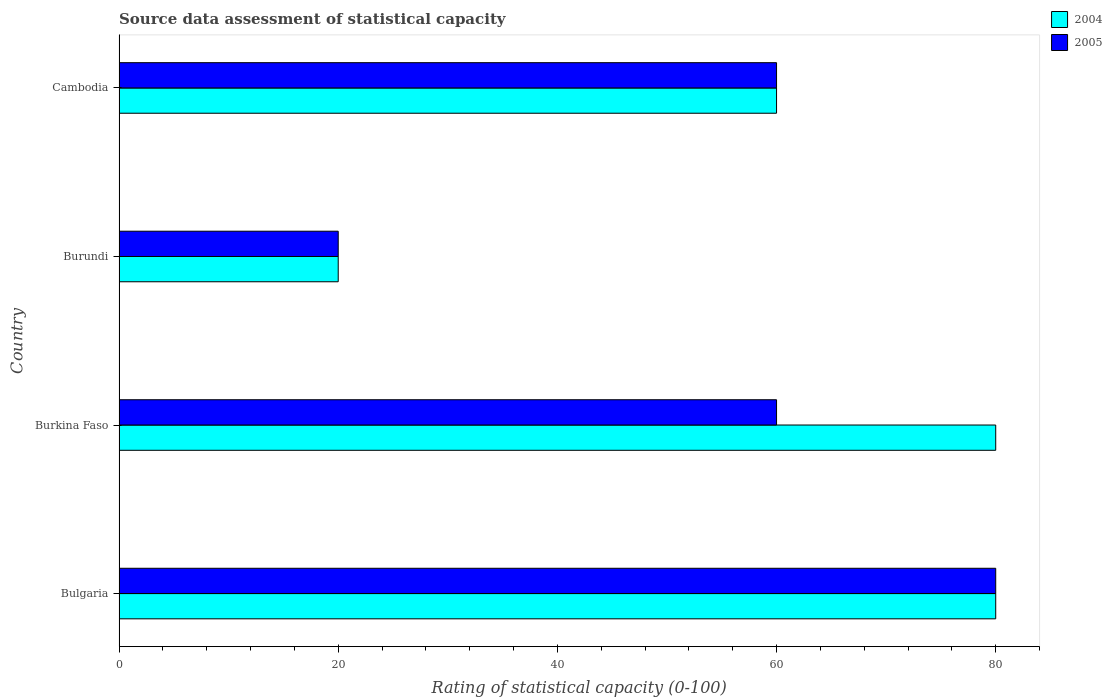How many different coloured bars are there?
Keep it short and to the point. 2. How many groups of bars are there?
Provide a succinct answer. 4. How many bars are there on the 1st tick from the top?
Keep it short and to the point. 2. What is the label of the 2nd group of bars from the top?
Ensure brevity in your answer.  Burundi. What is the rating of statistical capacity in 2004 in Cambodia?
Offer a very short reply. 60. Across all countries, what is the maximum rating of statistical capacity in 2004?
Give a very brief answer. 80. In which country was the rating of statistical capacity in 2004 maximum?
Your answer should be very brief. Bulgaria. In which country was the rating of statistical capacity in 2005 minimum?
Your answer should be very brief. Burundi. What is the total rating of statistical capacity in 2005 in the graph?
Give a very brief answer. 220. What is the difference between the rating of statistical capacity in 2004 in Bulgaria and the rating of statistical capacity in 2005 in Burundi?
Make the answer very short. 60. In how many countries, is the rating of statistical capacity in 2004 greater than 76 ?
Offer a terse response. 2. What is the ratio of the rating of statistical capacity in 2004 in Bulgaria to that in Burundi?
Provide a succinct answer. 4. Is the difference between the rating of statistical capacity in 2004 in Bulgaria and Burkina Faso greater than the difference between the rating of statistical capacity in 2005 in Bulgaria and Burkina Faso?
Your response must be concise. No. What is the difference between the highest and the second highest rating of statistical capacity in 2004?
Give a very brief answer. 0. In how many countries, is the rating of statistical capacity in 2004 greater than the average rating of statistical capacity in 2004 taken over all countries?
Provide a short and direct response. 2. Is the sum of the rating of statistical capacity in 2005 in Burkina Faso and Burundi greater than the maximum rating of statistical capacity in 2004 across all countries?
Your answer should be very brief. No. What does the 2nd bar from the bottom in Cambodia represents?
Your answer should be very brief. 2005. Are the values on the major ticks of X-axis written in scientific E-notation?
Provide a short and direct response. No. Does the graph contain grids?
Provide a succinct answer. No. How are the legend labels stacked?
Give a very brief answer. Vertical. What is the title of the graph?
Ensure brevity in your answer.  Source data assessment of statistical capacity. What is the label or title of the X-axis?
Make the answer very short. Rating of statistical capacity (0-100). What is the Rating of statistical capacity (0-100) in 2004 in Burundi?
Give a very brief answer. 20. Across all countries, what is the maximum Rating of statistical capacity (0-100) in 2004?
Your response must be concise. 80. What is the total Rating of statistical capacity (0-100) in 2004 in the graph?
Offer a very short reply. 240. What is the total Rating of statistical capacity (0-100) of 2005 in the graph?
Offer a very short reply. 220. What is the difference between the Rating of statistical capacity (0-100) in 2004 in Bulgaria and that in Burkina Faso?
Your answer should be compact. 0. What is the difference between the Rating of statistical capacity (0-100) in 2005 in Bulgaria and that in Burundi?
Make the answer very short. 60. What is the difference between the Rating of statistical capacity (0-100) in 2004 in Bulgaria and that in Cambodia?
Provide a short and direct response. 20. What is the difference between the Rating of statistical capacity (0-100) of 2005 in Burkina Faso and that in Burundi?
Offer a terse response. 40. What is the difference between the Rating of statistical capacity (0-100) in 2004 in Burkina Faso and that in Cambodia?
Offer a very short reply. 20. What is the difference between the Rating of statistical capacity (0-100) of 2005 in Burkina Faso and that in Cambodia?
Offer a terse response. 0. What is the difference between the Rating of statistical capacity (0-100) of 2005 in Burundi and that in Cambodia?
Your response must be concise. -40. What is the difference between the Rating of statistical capacity (0-100) of 2004 in Bulgaria and the Rating of statistical capacity (0-100) of 2005 in Burundi?
Keep it short and to the point. 60. What is the difference between the Rating of statistical capacity (0-100) in 2004 in Bulgaria and the Rating of statistical capacity (0-100) in 2005 in Cambodia?
Offer a terse response. 20. What is the difference between the Rating of statistical capacity (0-100) of 2004 in Burkina Faso and the Rating of statistical capacity (0-100) of 2005 in Burundi?
Make the answer very short. 60. What is the difference between the Rating of statistical capacity (0-100) in 2004 and Rating of statistical capacity (0-100) in 2005 in Burkina Faso?
Offer a very short reply. 20. What is the ratio of the Rating of statistical capacity (0-100) of 2004 in Bulgaria to that in Burkina Faso?
Provide a succinct answer. 1. What is the ratio of the Rating of statistical capacity (0-100) of 2005 in Bulgaria to that in Burkina Faso?
Give a very brief answer. 1.33. What is the ratio of the Rating of statistical capacity (0-100) of 2005 in Burkina Faso to that in Burundi?
Your answer should be compact. 3. What is the ratio of the Rating of statistical capacity (0-100) of 2004 in Burundi to that in Cambodia?
Give a very brief answer. 0.33. What is the ratio of the Rating of statistical capacity (0-100) in 2005 in Burundi to that in Cambodia?
Keep it short and to the point. 0.33. What is the difference between the highest and the lowest Rating of statistical capacity (0-100) of 2005?
Offer a terse response. 60. 